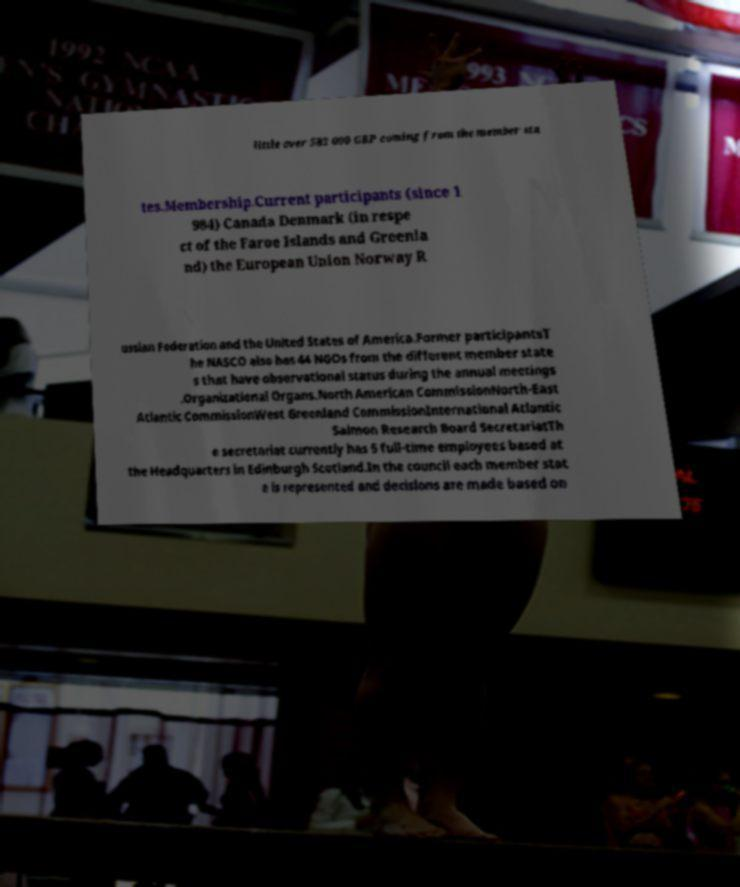Could you extract and type out the text from this image? little over 583 000 GBP coming from the member sta tes.Membership.Current participants (since 1 984) Canada Denmark (in respe ct of the Faroe Islands and Greenla nd) the European Union Norway R ussian Federation and the United States of America.Former participantsT he NASCO also has 44 NGOs from the different member state s that have observational status during the annual meetings .Organizational Organs.North American CommissionNorth-East Atlantic CommissionWest Greenland CommissionInternational Atlantic Salmon Research Board SecretariatTh e secretariat currently has 5 full-time employees based at the Headquarters in Edinburgh Scotland.In the council each member stat e is represented and decisions are made based on 